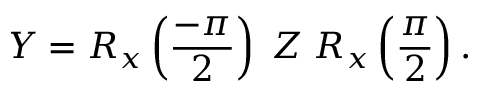<formula> <loc_0><loc_0><loc_500><loc_500>Y = R _ { x } \left ( \frac { - \pi } { 2 } \right ) \, Z \, R _ { x } \left ( \frac { \pi } { 2 } \right ) .</formula> 